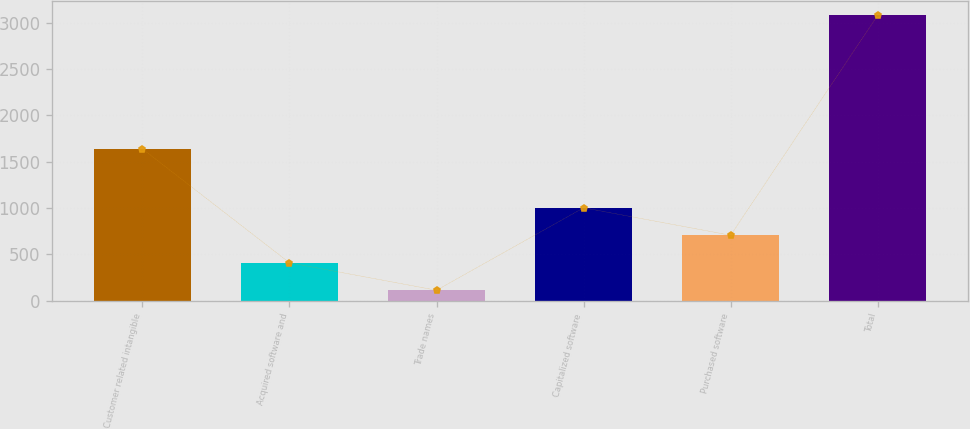Convert chart to OTSL. <chart><loc_0><loc_0><loc_500><loc_500><bar_chart><fcel>Customer related intangible<fcel>Acquired software and<fcel>Trade names<fcel>Capitalized software<fcel>Purchased software<fcel>Total<nl><fcel>1638<fcel>410.4<fcel>114<fcel>1003.2<fcel>706.8<fcel>3078<nl></chart> 